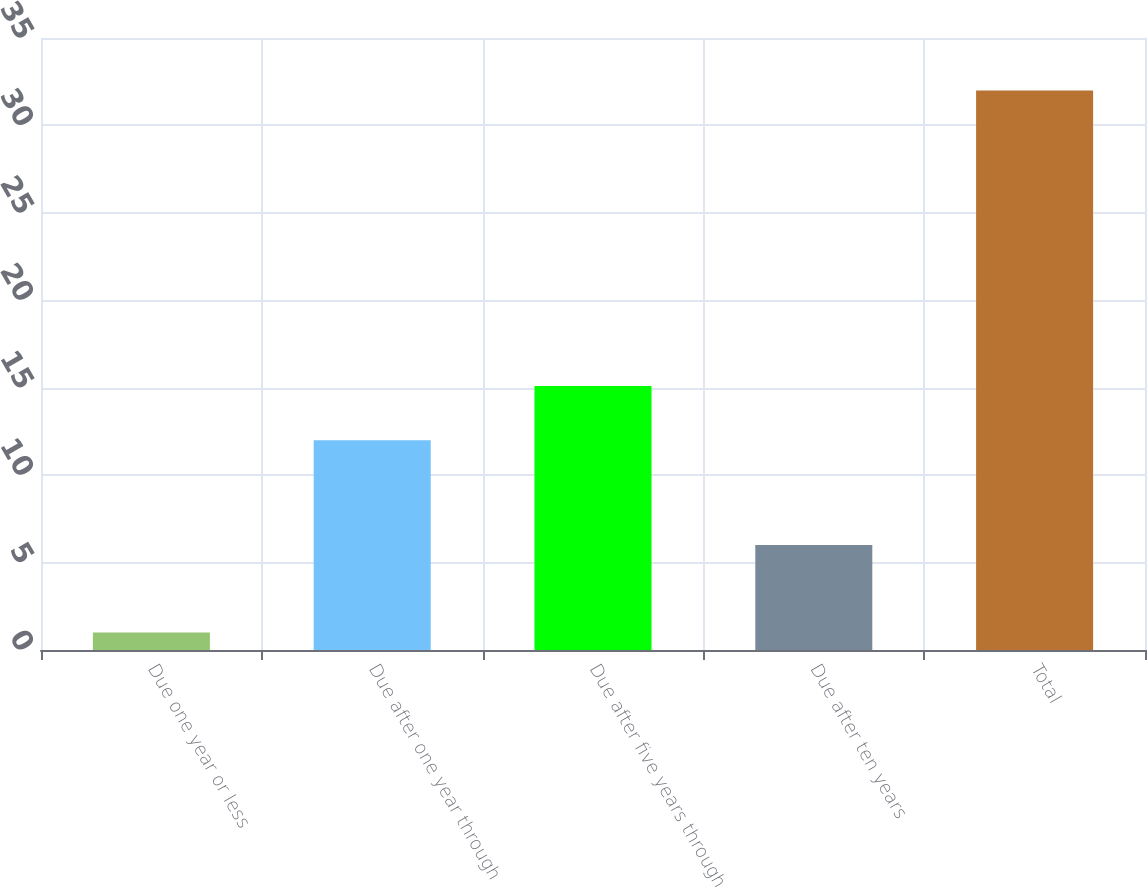Convert chart. <chart><loc_0><loc_0><loc_500><loc_500><bar_chart><fcel>Due one year or less<fcel>Due after one year through<fcel>Due after five years through<fcel>Due after ten years<fcel>Total<nl><fcel>1<fcel>12<fcel>15.1<fcel>6<fcel>32<nl></chart> 